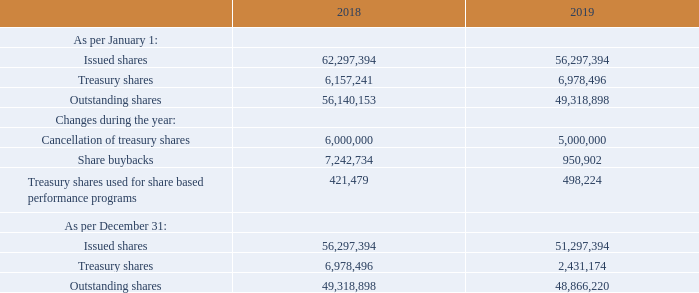SHARE INFORMATION
On December 31, 2019, the total number of issued common shares of ASMI amounted to 51,297,394 compared to 56,297,394 at year-end 2018. The decrease was the result of the cancellation of 5 million treasury shares that was approved by the Annual General Meeting of Shareholders (AGM) on May 20, 2019, and became effective on July 23, 2019.
On December 31, 2019, we had 48,866,220 outstanding common shares excluding 2,431,174 treasury shares. This compared to 49,318,898 outstanding common shares and 6,978,496 treasury shares at year-end 2018. Besides the cancellation of 5 million treasury shares in July 2019, the change in the number of treasury shares in 2019 was the result of approximately 951,000 repurchased shares and approximately 498,000 treasury shares that were used as part of share based payments.
On December 31, 2019, 48,583,340 of the outstanding common shares were registered with our transfer agent in the Netherlands, ABN AMRO Bank NV; and 282,880 were registered with our transfer agent in the United States, Citibank, NA, New York.
On February 25, 2020, ASMI announced that it will propose to the AGM 2020 the cancellation of 1.5 million treasury shares, as the number of 2.4 million treasury shares held at that date was more than sufficient to cover our outstanding options and restricted/performance shares.
Where are the outstanding common shares registered with in 2019? Netherlands, abn amro bank nv, united states, citibank, na, new york. What are the issued shares as per january 1 2019? 56,297,394. Why would it be proposed that treasury share are to be cancelled? The number of 2.4 million treasury shares held at that date was more than sufficient to cover our outstanding options and restricted/performance shares. What is the average number of Outstanding shares as per january 1 2018 and 2019?  (56,140,153+ 49,318,898 )/2
Answer: 52729525.5. At which point of time was the Outstanding shares the greatest? For COL 3 and 4 rows 5 and 13 find the largest number and the corresponding time period
Answer: january 1, 2018. What is the change in Outstanding shares as per December 31, 2019 as compared to January 1, 2018?  48,866,220-56,140,153
Answer: -7273933. 